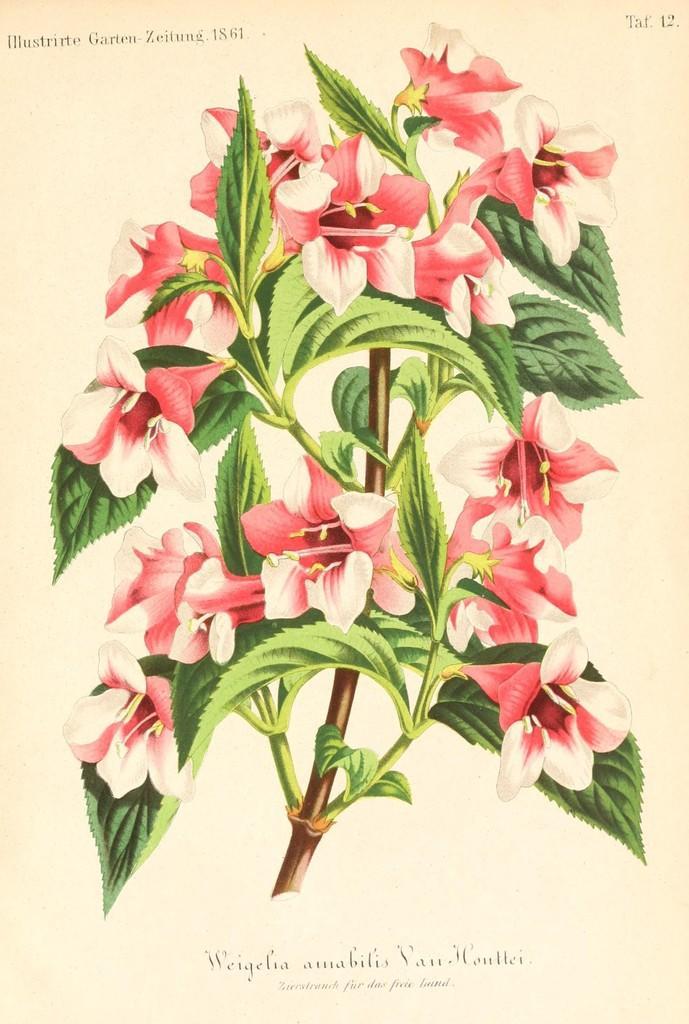Please provide a concise description of this image. In the center of this picture we can see an image of flowers and green leaves of a plant and we can see the text and numbers on the image. 